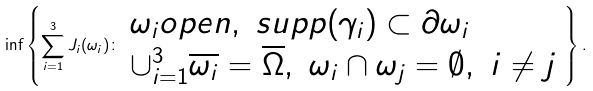<formula> <loc_0><loc_0><loc_500><loc_500>\inf \left \{ \sum _ { i = 1 } ^ { 3 } J _ { i } ( \omega _ { i } ) \colon \begin{array} { l } \omega _ { i } o p e n , \ s u p p ( \gamma _ { i } ) \subset \partial \omega _ { i } \\ \cup _ { i = 1 } ^ { 3 } \overline { \omega _ { i } } = \overline { \Omega } , \ \omega _ { i } \cap \omega _ { j } = \emptyset , \ i \neq j \end{array} \right \} .</formula> 